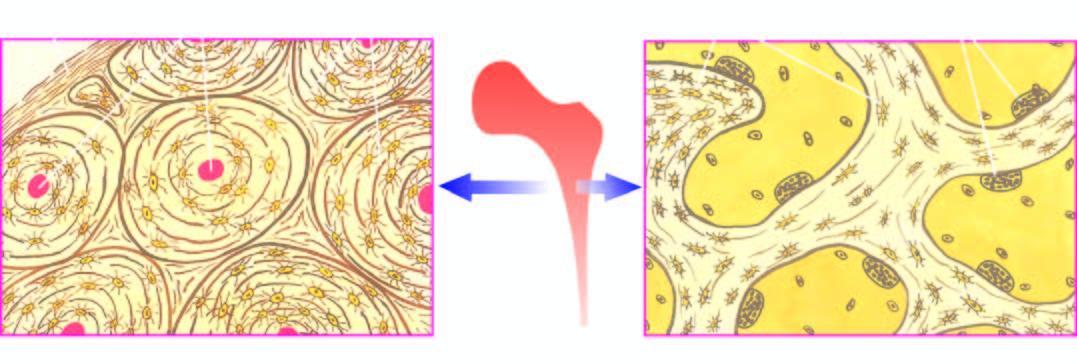where does the trabecular bone forming the marrow space show?
Answer the question using a single word or phrase. At the margins 